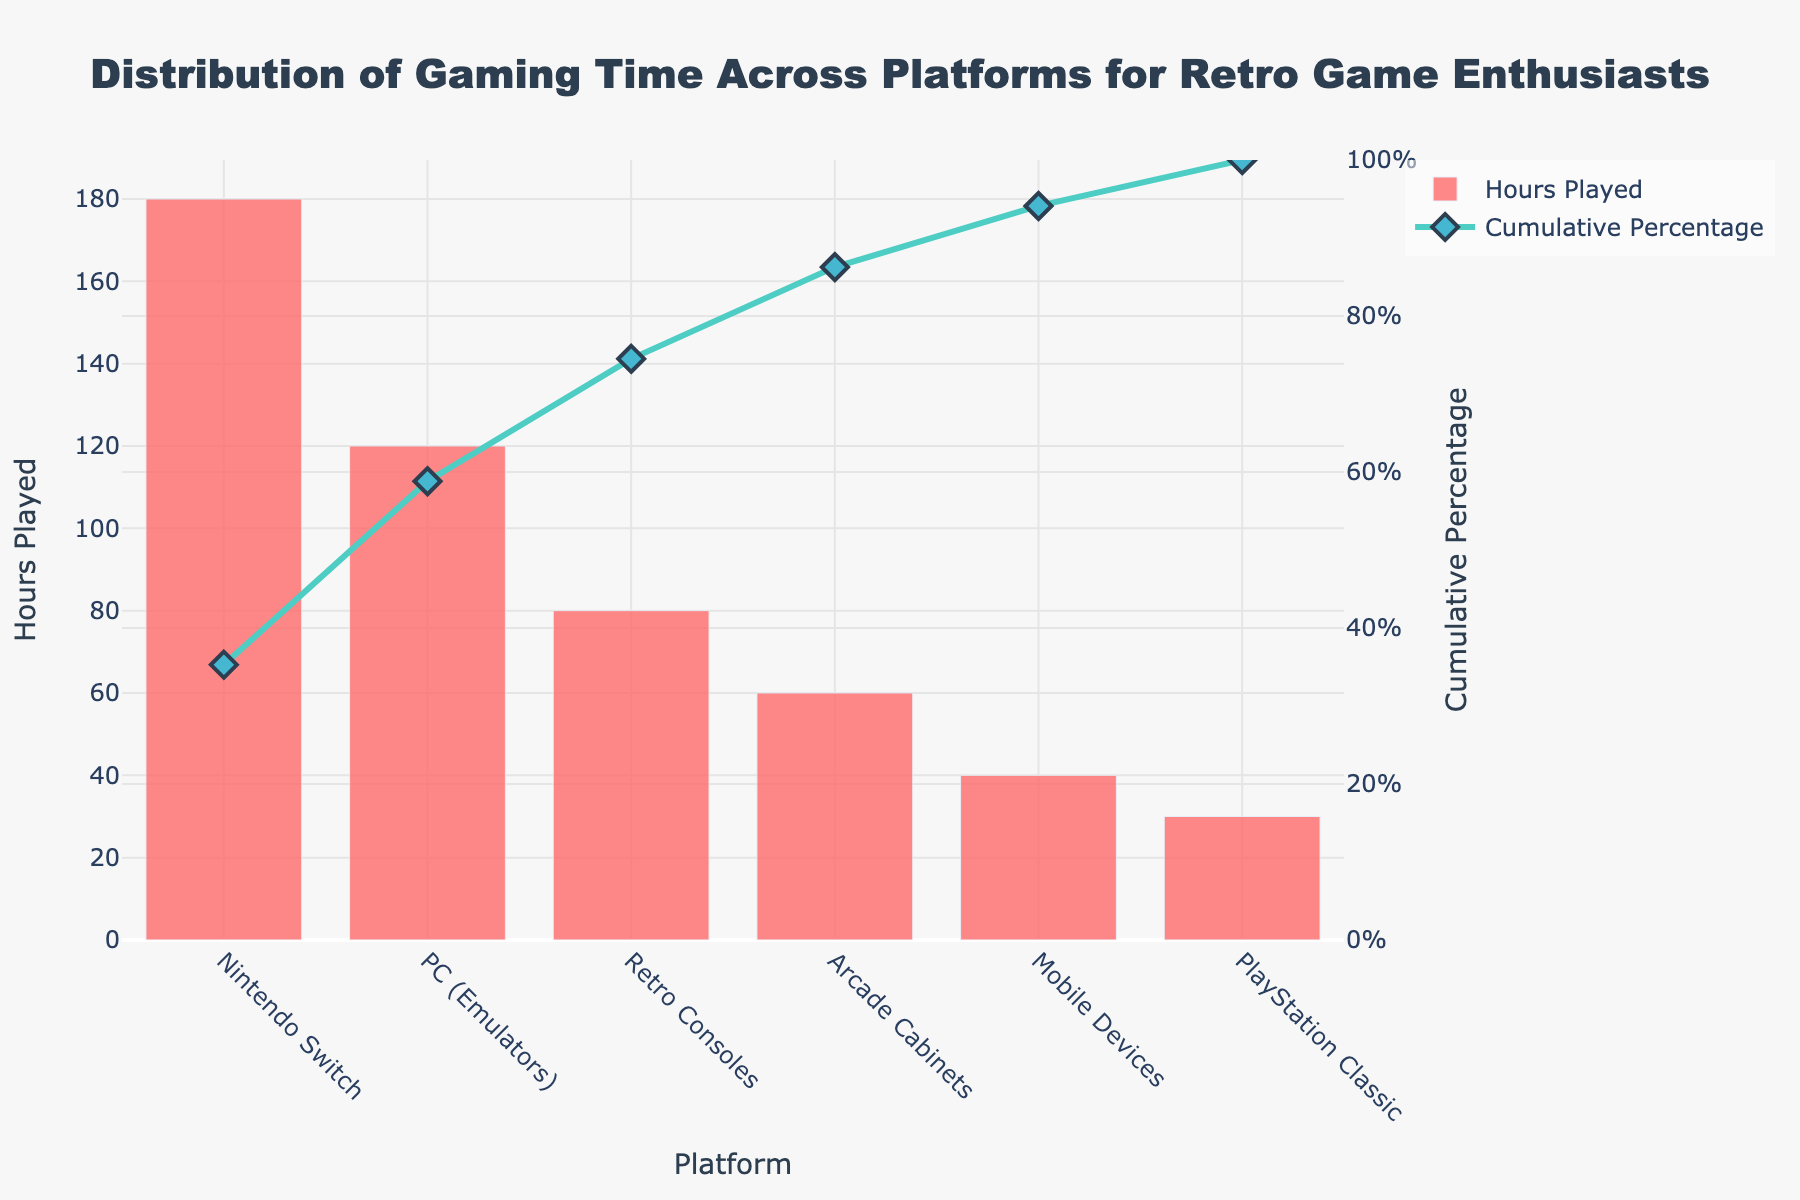What platform has the highest number of hours played? From the bar chart, Nintendo Switch has the highest bar, representing the highest number of hours played.
Answer: Nintendo Switch What is the cumulative percentage after adding hours from the top two platforms? The cumulative percentages for Nintendo Switch and PC (Emulators) sum to 35.29% and 23.53% respectively. Adding these percentages: 35.29% + 23.53% = 58.82%.
Answer: 58.82% Which platform has the lowest number of hours played? From the bar chart, the platform with the smallest bar is PlayStation Classic, representing the lowest number of hours played.
Answer: PlayStation Classic How does the number of hours played on Arcade Cabinets compare to Mobile Devices? The bar for Arcade Cabinets is higher than the bar for Mobile Devices, indicating that Arcade Cabinets have more hours played. Specifically, it shows 60 hours for Arcade Cabinets and 40 hours for Mobile Devices.
Answer: Arcade Cabinets have more hours What is the total number of hours played across all platforms? Summing the hours played for all platforms: 180 (Nintendo Switch) + 120 (PC Emulators) + 80 (Retro Consoles) + 60 (Arcade Cabinets) + 40 (Mobile Devices) + 30 (PlayStation Classic) = 510 hours.
Answer: 510 hours What percentage of the total gaming time is spent on Retro Consoles? Retro Consoles account for 80 hours out of the total 510 hours played. The percentage is calculated by (80/510) * 100 ≈ 15.69%.
Answer: 15.69% At which platform does the cumulative percentage first exceed 50%? The cumulative percentage exceeds 50% when adding the PC (Emulators) with a cumulative total of 58.82%, covering Nintendo Switch and PC combined as shown by the line graph.
Answer: PC (Emulators) If hours played on Mobile Devices increase by 20 hours, what would be the new cumulative percentage for Mobile Devices? Currently, Mobile Devices contribute 40 hours with a cumulative percentage of 94.12%. Increasing by 20 hours, the new total becomes 60 hours. With the new total hours being 530 (510+20), the percentage for Mobile Devices becomes (60/530)*100 ≈ 11.32%. The preceding cumulative percentage is 86.27% (from Arcade Cabinets). Hence, the new cumulative percentage becomes 86.27% + 11.32% ≈ 97.59%.
Answer: 97.59% How much more time is spent on Nintendo Switch compared to PlayStation Classic? Nintendo Switch has 180 hours and PlayStation Classic has 30 hours. The difference is 180 - 30 = 150 hours.
Answer: 150 hours What platforms together contribute exactly or closest to 75% of the total hours played? Combining the cumulative percentages from the bar chart, the platforms under 75% would be Nintendo Switch (35.29%) and PC (Emulators) (23.53%), giving a total of 58.82%. Adding Retro Consoles at 15.69%, the cumulative percentage increases to 74.51%, which is closest to 75%. Therefore, Nintendo Switch, PC (Emulators), and Retro Consoles together contribute closest to 75%.
Answer: Nintendo Switch, PC (Emulators), and Retro Consoles 